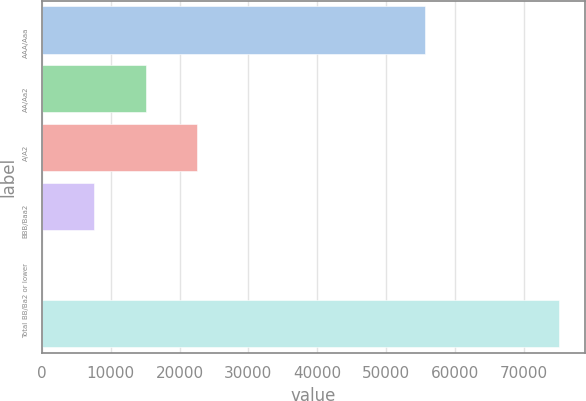<chart> <loc_0><loc_0><loc_500><loc_500><bar_chart><fcel>AAA/Aaa<fcel>AA/Aa2<fcel>A/A2<fcel>BBB/Baa2<fcel>BB/Ba2 or lower<fcel>Total<nl><fcel>55626<fcel>15097<fcel>22598<fcel>7596<fcel>95<fcel>75105<nl></chart> 